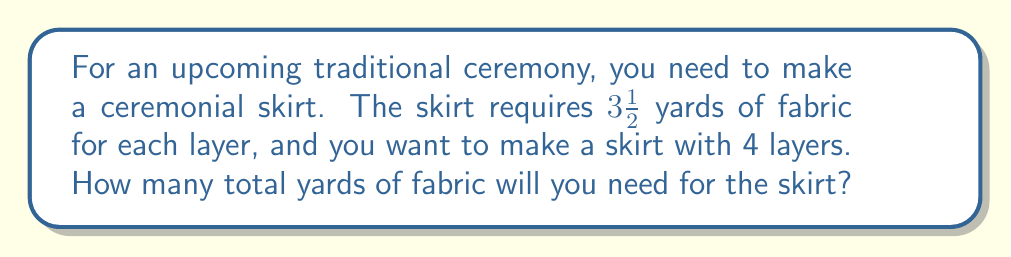Teach me how to tackle this problem. Let's approach this problem step by step:

1. We know that each layer of the skirt requires $3\frac{1}{2}$ yards of fabric.
   This can be written as a mixed number: $3\frac{1}{2} = 3.5$ yards

2. We need to make 4 layers for the skirt.

3. To find the total amount of fabric needed, we multiply the amount needed for one layer by the number of layers:

   $$ \text{Total fabric} = \text{Fabric per layer} \times \text{Number of layers} $$
   $$ \text{Total fabric} = 3\frac{1}{2} \times 4 $$

4. To multiply a mixed number by a whole number, we can convert the mixed number to an improper fraction:
   $$ 3\frac{1}{2} = \frac{7}{2} $$

5. Now we can multiply:
   $$ \frac{7}{2} \times 4 = \frac{28}{2} = 14 $$

Therefore, you will need 14 yards of fabric in total for the ceremonial skirt.
Answer: 14 yards 